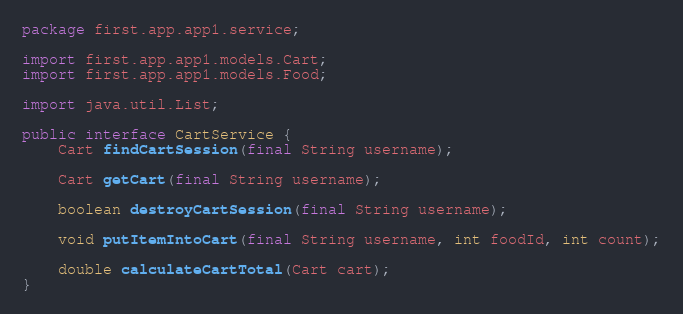Convert code to text. <code><loc_0><loc_0><loc_500><loc_500><_Java_>package first.app.app1.service;

import first.app.app1.models.Cart;
import first.app.app1.models.Food;

import java.util.List;

public interface CartService {
    Cart findCartSession(final String username);

    Cart getCart(final String username);

    boolean destroyCartSession(final String username);

    void putItemIntoCart(final String username, int foodId, int count);

    double calculateCartTotal(Cart cart);
}</code> 